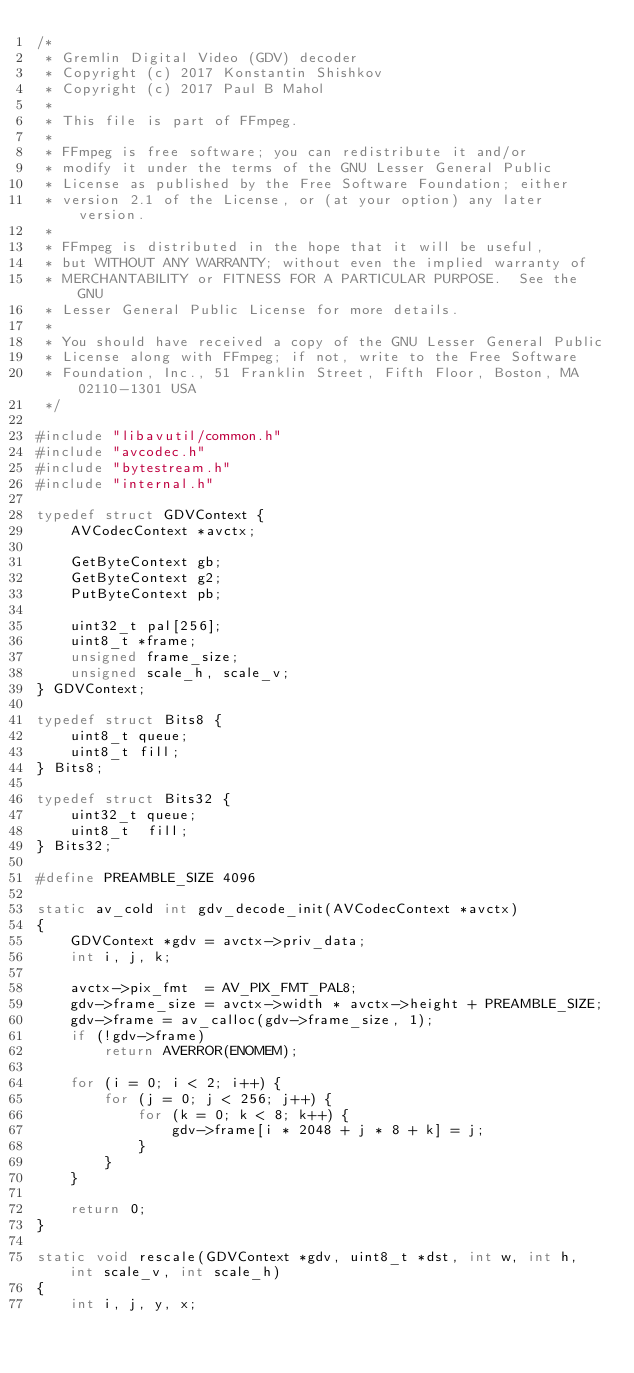<code> <loc_0><loc_0><loc_500><loc_500><_C_>/*
 * Gremlin Digital Video (GDV) decoder
 * Copyright (c) 2017 Konstantin Shishkov
 * Copyright (c) 2017 Paul B Mahol
 *
 * This file is part of FFmpeg.
 *
 * FFmpeg is free software; you can redistribute it and/or
 * modify it under the terms of the GNU Lesser General Public
 * License as published by the Free Software Foundation; either
 * version 2.1 of the License, or (at your option) any later version.
 *
 * FFmpeg is distributed in the hope that it will be useful,
 * but WITHOUT ANY WARRANTY; without even the implied warranty of
 * MERCHANTABILITY or FITNESS FOR A PARTICULAR PURPOSE.  See the GNU
 * Lesser General Public License for more details.
 *
 * You should have received a copy of the GNU Lesser General Public
 * License along with FFmpeg; if not, write to the Free Software
 * Foundation, Inc., 51 Franklin Street, Fifth Floor, Boston, MA 02110-1301 USA
 */

#include "libavutil/common.h"
#include "avcodec.h"
#include "bytestream.h"
#include "internal.h"

typedef struct GDVContext {
    AVCodecContext *avctx;

    GetByteContext gb;
    GetByteContext g2;
    PutByteContext pb;

    uint32_t pal[256];
    uint8_t *frame;
    unsigned frame_size;
    unsigned scale_h, scale_v;
} GDVContext;

typedef struct Bits8 {
    uint8_t queue;
    uint8_t fill;
} Bits8;

typedef struct Bits32 {
    uint32_t queue;
    uint8_t  fill;
} Bits32;

#define PREAMBLE_SIZE 4096

static av_cold int gdv_decode_init(AVCodecContext *avctx)
{
    GDVContext *gdv = avctx->priv_data;
    int i, j, k;

    avctx->pix_fmt  = AV_PIX_FMT_PAL8;
    gdv->frame_size = avctx->width * avctx->height + PREAMBLE_SIZE;
    gdv->frame = av_calloc(gdv->frame_size, 1);
    if (!gdv->frame)
        return AVERROR(ENOMEM);

    for (i = 0; i < 2; i++) {
        for (j = 0; j < 256; j++) {
            for (k = 0; k < 8; k++) {
                gdv->frame[i * 2048 + j * 8 + k] = j;
            }
        }
    }

    return 0;
}

static void rescale(GDVContext *gdv, uint8_t *dst, int w, int h, int scale_v, int scale_h)
{
    int i, j, y, x;
</code> 